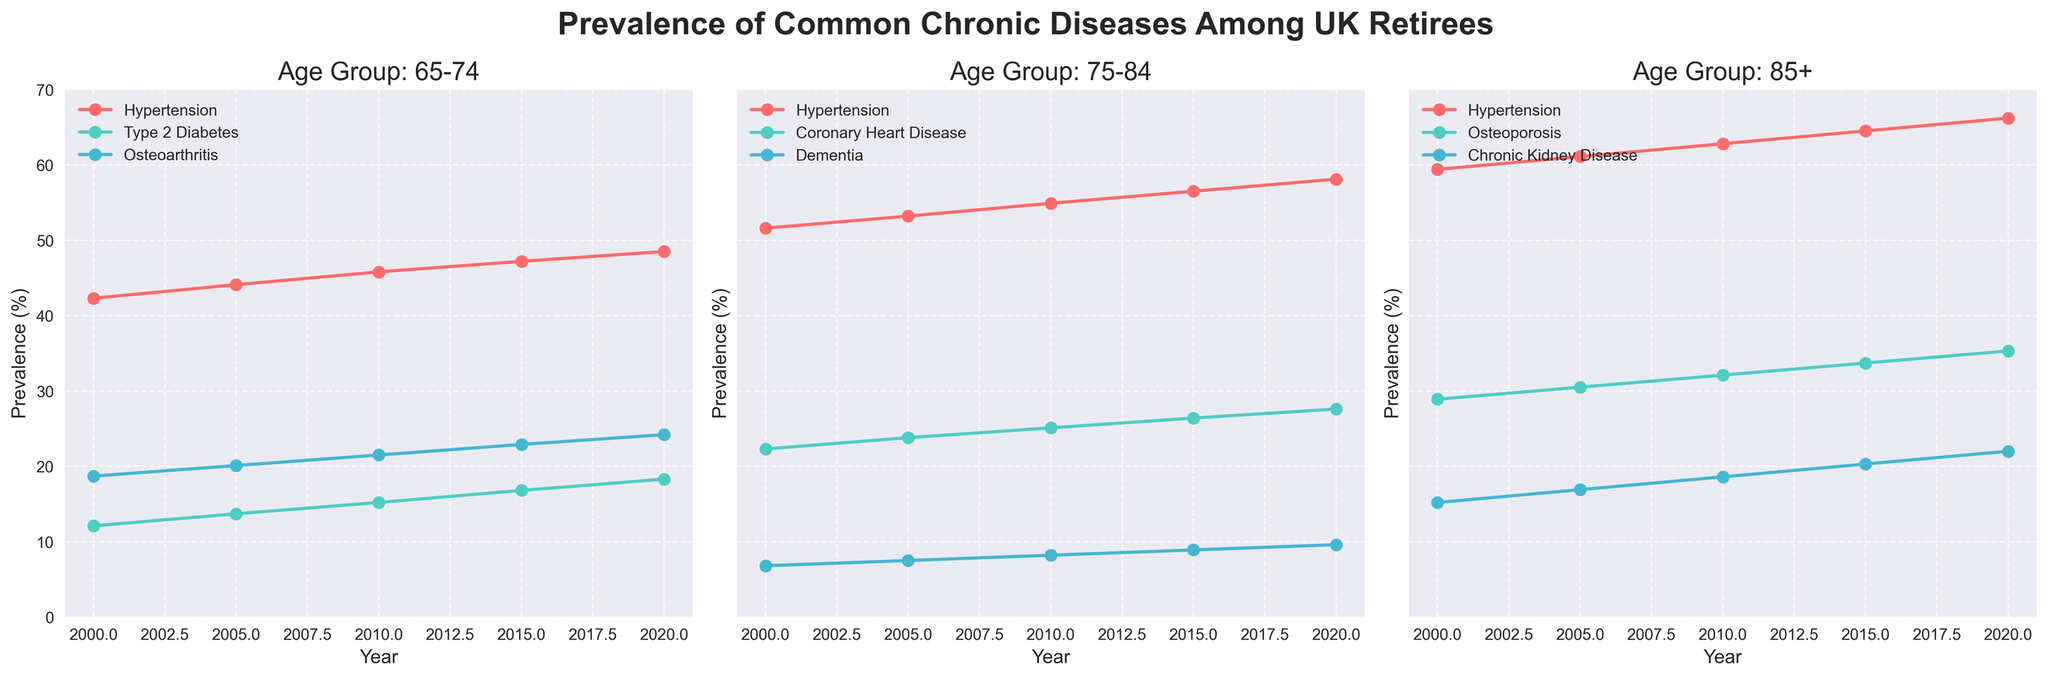What is the prevalence of hypertension in the 75-84 age group in 2005? Look at the line for hypertension in the age group 75-84 on the chart and find the point corresponding to the year 2005. The prevalence value at that point is the answer.
Answer: 53.2% Which age group had the highest prevalence of hypertension in 2020? Compare the prevalence of hypertension by looking at the endpoints of the hypertension lines for all three age groups in 2020. The age group with the highest endpoint indicates the highest prevalence.
Answer: 85+ What is the difference in the prevalence of Type 2 Diabetes between 2000 and 2020 for the 65-74 age group? Find the points on the Type 2 Diabetes line for the 65-74 age group corresponding to the years 2000 and 2020, then subtract the 2000 value from the 2020 value.
Answer: 6.2% How does the prevalence of dementia in the 75-84 age group change from 2000 to 2015? Look at the dementia line for the age group 75-84 and find the points corresponding to the years 2000 and 2015. Determine the change by subtracting the 2000 value from the 2015 value.
Answer: 2.1% Which disease had the steadiest increase in prevalence from 2000 to 2020 in the 85+ age group? Examine all the lines for the 85+ age group and identify the one that shows a consistent upward trend with no major fluctuations from 2000 to 2020.
Answer: Hypertension What is the average prevalence of osteoarthritis in the 65-74 age group across all the years? Sum the prevalence values for osteoarthritis in the 65-74 age group from 2000, 2005, 2010, 2015, and 2020, then divide by 5 (the number of years).
Answer: 21.28% Is the prevalence of chronic kidney disease in the 85+ age group greater in 2015 or 2020? Compare the points on the chronic kidney disease line for the 85+ age group for the years 2015 and 2020. Determine which is higher.
Answer: 2020 Which disease has the smallest increase in prevalence from 2000 to 2020 in any age group? Find the increase in prevalence from 2000 to 2020 for each disease in each age group and determine which one has the smallest increase.
Answer: Dementia (75-84 age group) What is the total increase in prevalence of coronary heart disease in the 75-84 age group from 2000 to 2020? Find the values for coronary heart disease in the 75-84 age group for 2000 and 2020, then subtract the 2000 value from the 2020 value to get the total increase.
Answer: 5.3 